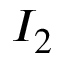<formula> <loc_0><loc_0><loc_500><loc_500>I _ { 2 }</formula> 